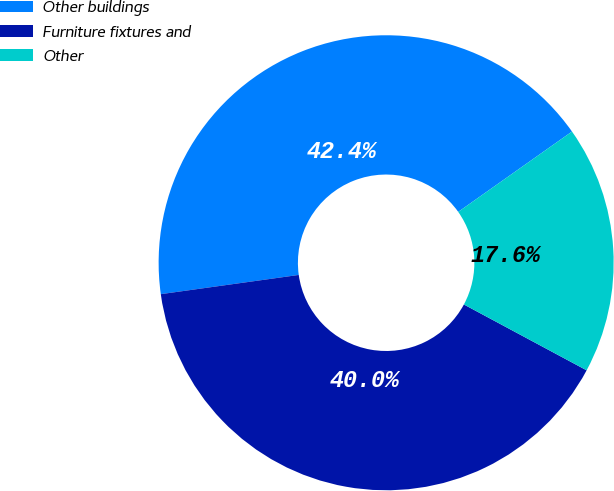Convert chart. <chart><loc_0><loc_0><loc_500><loc_500><pie_chart><fcel>Other buildings<fcel>Furniture fixtures and<fcel>Other<nl><fcel>42.42%<fcel>39.96%<fcel>17.62%<nl></chart> 